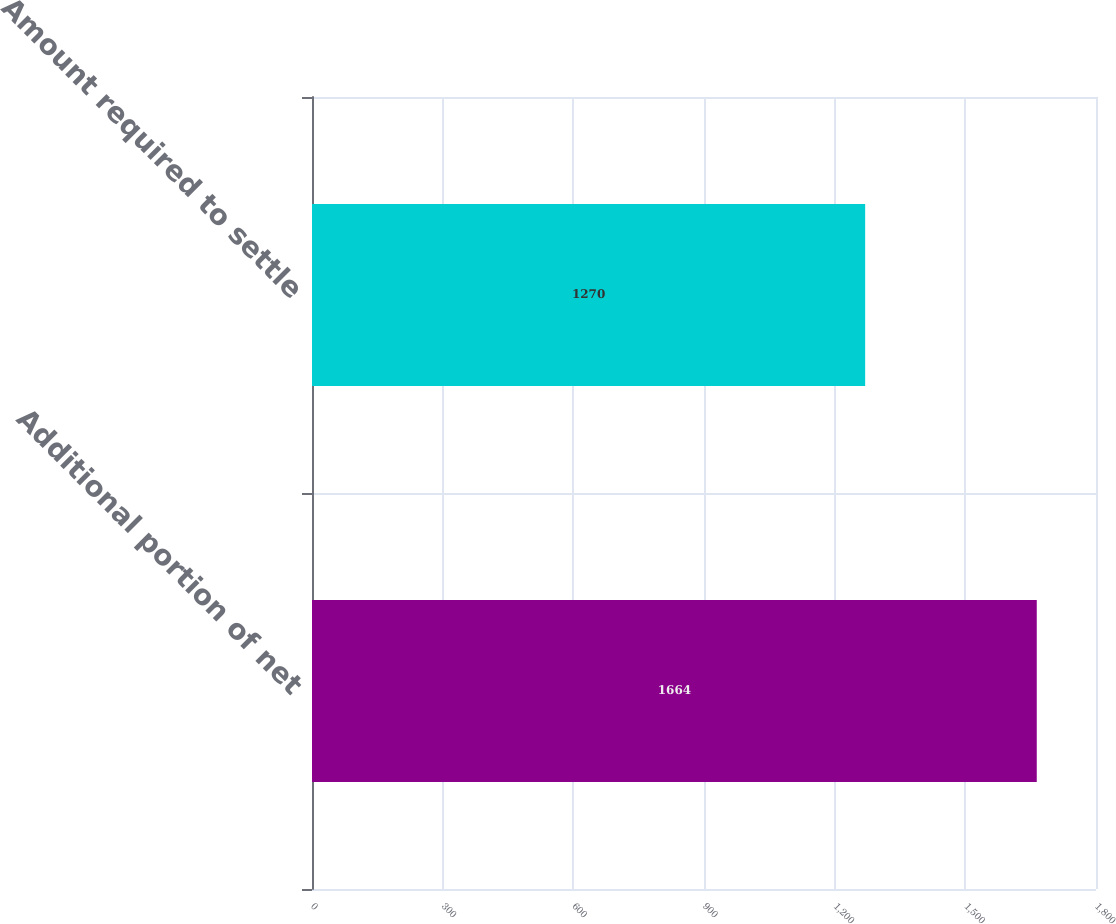Convert chart to OTSL. <chart><loc_0><loc_0><loc_500><loc_500><bar_chart><fcel>Additional portion of net<fcel>Amount required to settle<nl><fcel>1664<fcel>1270<nl></chart> 